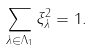<formula> <loc_0><loc_0><loc_500><loc_500>\sum _ { \lambda \in \Lambda _ { 1 } } \xi ^ { 2 } _ { \lambda } = 1 .</formula> 